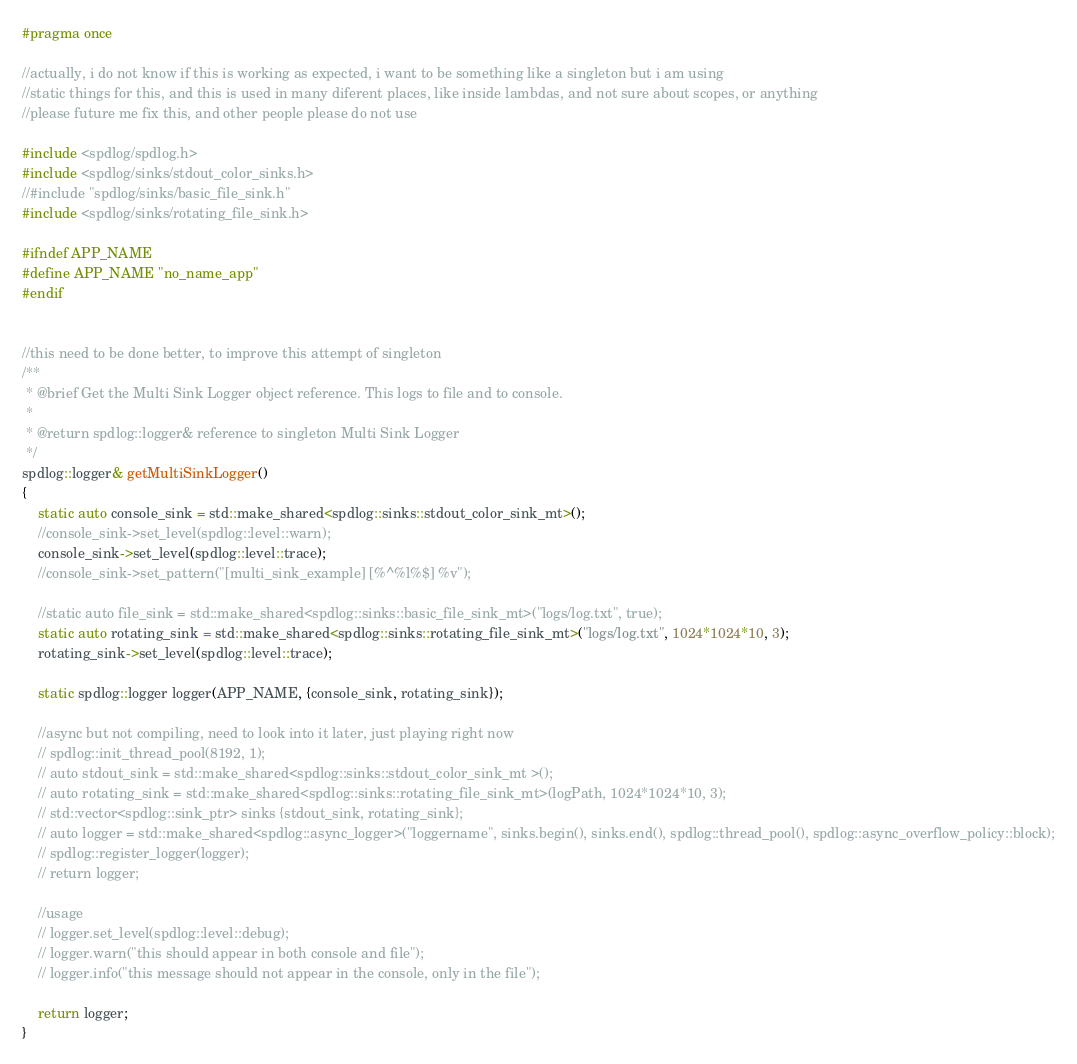<code> <loc_0><loc_0><loc_500><loc_500><_C_>#pragma once

//actually, i do not know if this is working as expected, i want to be something like a singleton but i am using
//static things for this, and this is used in many diferent places, like inside lambdas, and not sure about scopes, or anything
//please future me fix this, and other people please do not use

#include <spdlog/spdlog.h>
#include <spdlog/sinks/stdout_color_sinks.h>
//#include "spdlog/sinks/basic_file_sink.h"
#include <spdlog/sinks/rotating_file_sink.h>

#ifndef APP_NAME
#define APP_NAME "no_name_app"
#endif


//this need to be done better, to improve this attempt of singleton 
/**
 * @brief Get the Multi Sink Logger object reference. This logs to file and to console.
 * 
 * @return spdlog::logger& reference to singleton Multi Sink Logger
 */
spdlog::logger& getMultiSinkLogger()
{
    static auto console_sink = std::make_shared<spdlog::sinks::stdout_color_sink_mt>();
    //console_sink->set_level(spdlog::level::warn);
    console_sink->set_level(spdlog::level::trace);
    //console_sink->set_pattern("[multi_sink_example] [%^%l%$] %v");

    //static auto file_sink = std::make_shared<spdlog::sinks::basic_file_sink_mt>("logs/log.txt", true);
    static auto rotating_sink = std::make_shared<spdlog::sinks::rotating_file_sink_mt>("logs/log.txt", 1024*1024*10, 3);
    rotating_sink->set_level(spdlog::level::trace);

    static spdlog::logger logger(APP_NAME, {console_sink, rotating_sink});

    //async but not compiling, need to look into it later, just playing right now
    // spdlog::init_thread_pool(8192, 1);
    // auto stdout_sink = std::make_shared<spdlog::sinks::stdout_color_sink_mt >();
    // auto rotating_sink = std::make_shared<spdlog::sinks::rotating_file_sink_mt>(logPath, 1024*1024*10, 3);
    // std::vector<spdlog::sink_ptr> sinks {stdout_sink, rotating_sink};
    // auto logger = std::make_shared<spdlog::async_logger>("loggername", sinks.begin(), sinks.end(), spdlog::thread_pool(), spdlog::async_overflow_policy::block);
    // spdlog::register_logger(logger);
    // return logger;

    //usage
    // logger.set_level(spdlog::level::debug);
    // logger.warn("this should appear in both console and file");
    // logger.info("this message should not appear in the console, only in the file");

    return logger;
}</code> 